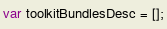Convert code to text. <code><loc_0><loc_0><loc_500><loc_500><_JavaScript_>var toolkitBundlesDesc = [];</code> 